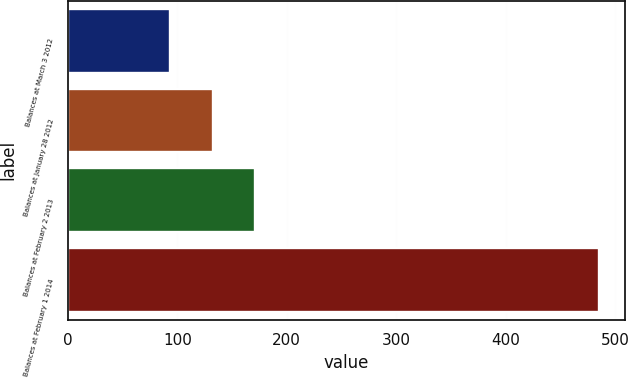Convert chart. <chart><loc_0><loc_0><loc_500><loc_500><bar_chart><fcel>Balances at March 3 2012<fcel>Balances at January 28 2012<fcel>Balances at February 2 2013<fcel>Balances at February 1 2014<nl><fcel>93<fcel>132.2<fcel>171.4<fcel>485<nl></chart> 